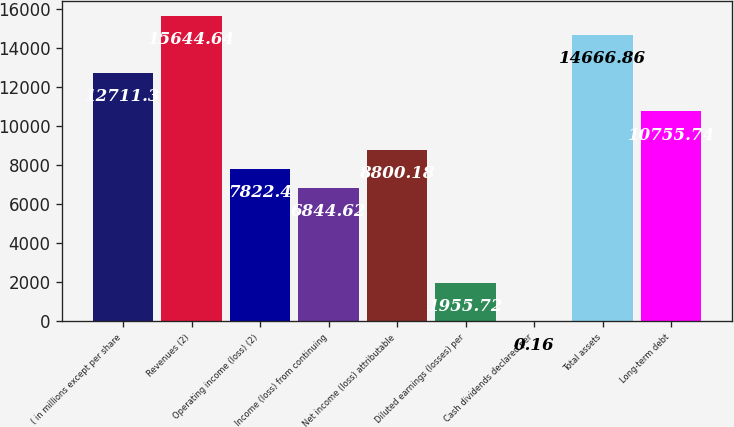Convert chart. <chart><loc_0><loc_0><loc_500><loc_500><bar_chart><fcel>( in millions except per share<fcel>Revenues (2)<fcel>Operating income (loss) (2)<fcel>Income (loss) from continuing<fcel>Net income (loss) attributable<fcel>Diluted earnings (losses) per<fcel>Cash dividends declared per<fcel>Total assets<fcel>Long-term debt<nl><fcel>12711.3<fcel>15644.6<fcel>7822.4<fcel>6844.62<fcel>8800.18<fcel>1955.72<fcel>0.16<fcel>14666.9<fcel>10755.7<nl></chart> 